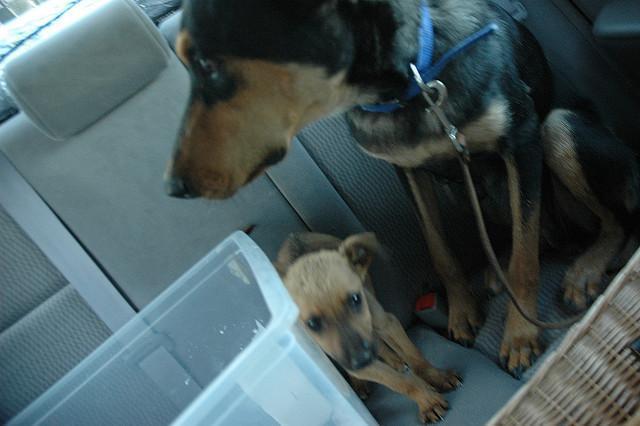How many dogs are there?
Give a very brief answer. 2. How many people are holding a surfboard?
Give a very brief answer. 0. 